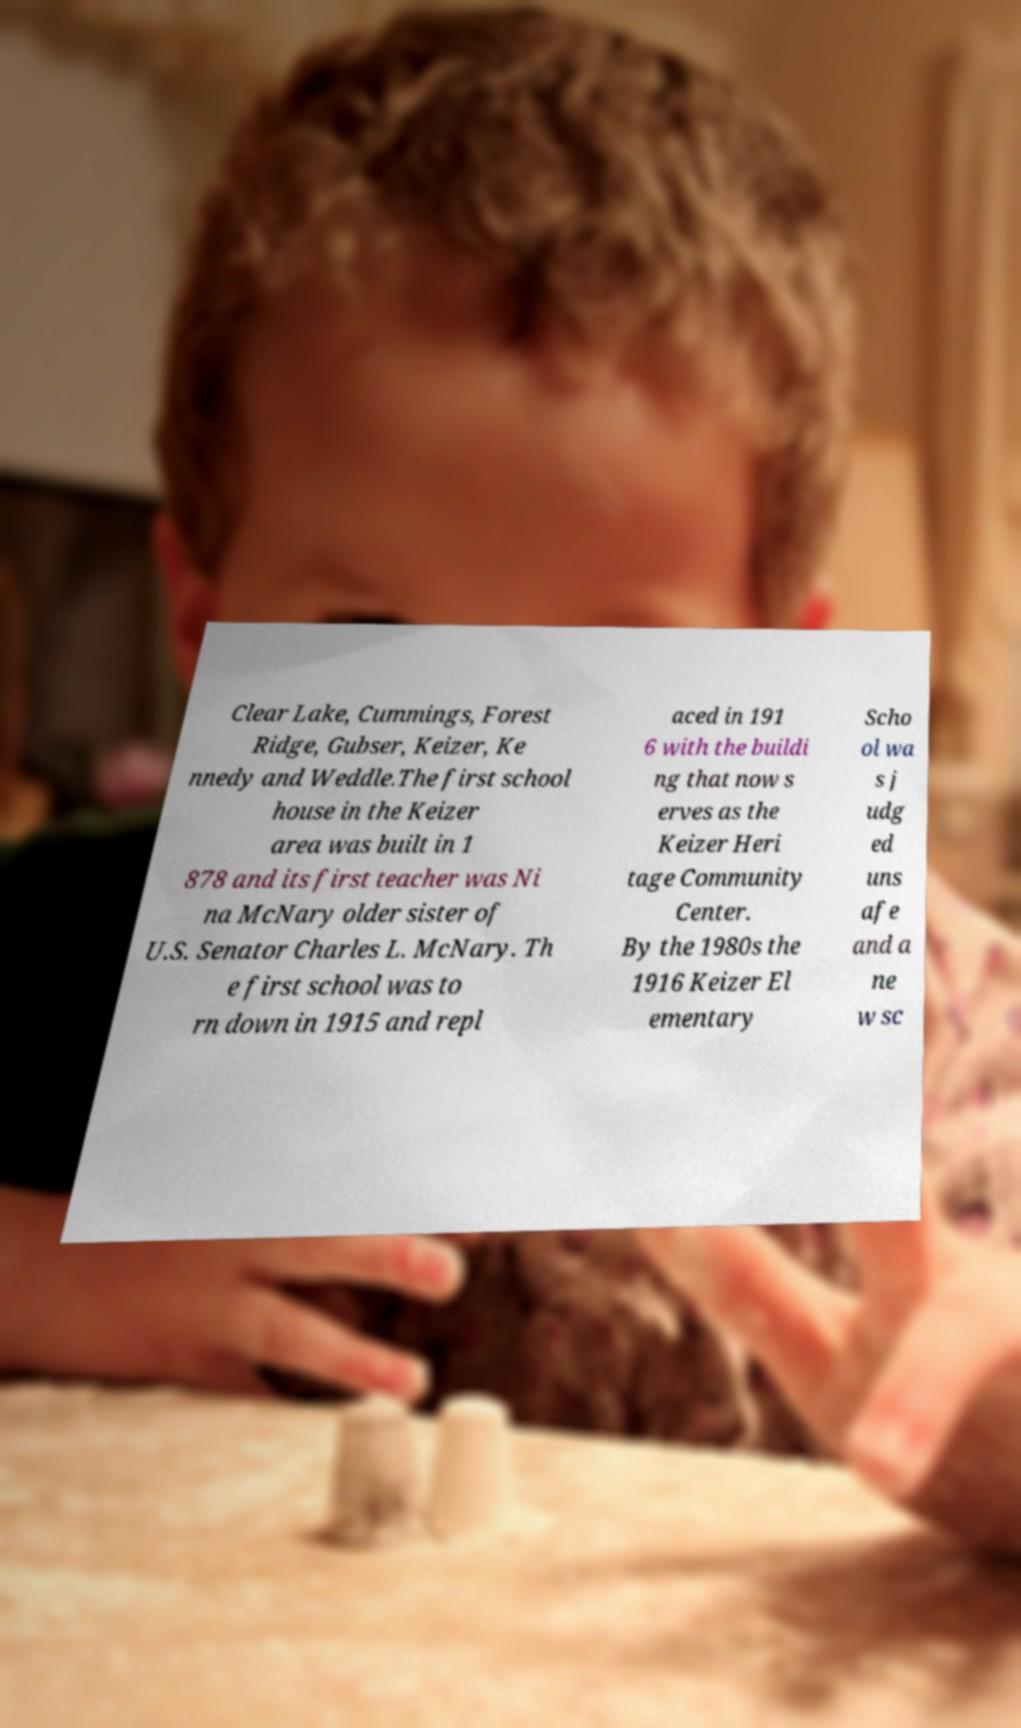What messages or text are displayed in this image? I need them in a readable, typed format. Clear Lake, Cummings, Forest Ridge, Gubser, Keizer, Ke nnedy and Weddle.The first school house in the Keizer area was built in 1 878 and its first teacher was Ni na McNary older sister of U.S. Senator Charles L. McNary. Th e first school was to rn down in 1915 and repl aced in 191 6 with the buildi ng that now s erves as the Keizer Heri tage Community Center. By the 1980s the 1916 Keizer El ementary Scho ol wa s j udg ed uns afe and a ne w sc 